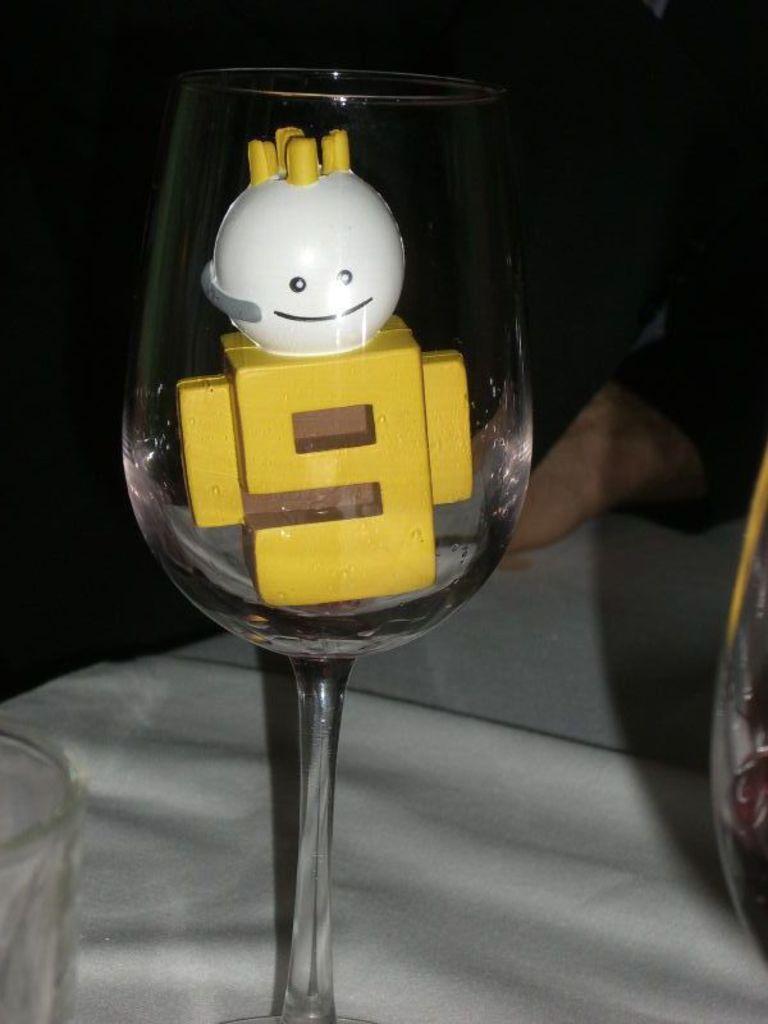Could you give a brief overview of what you see in this image? In this picture we can see one toy is placed in the glass. 